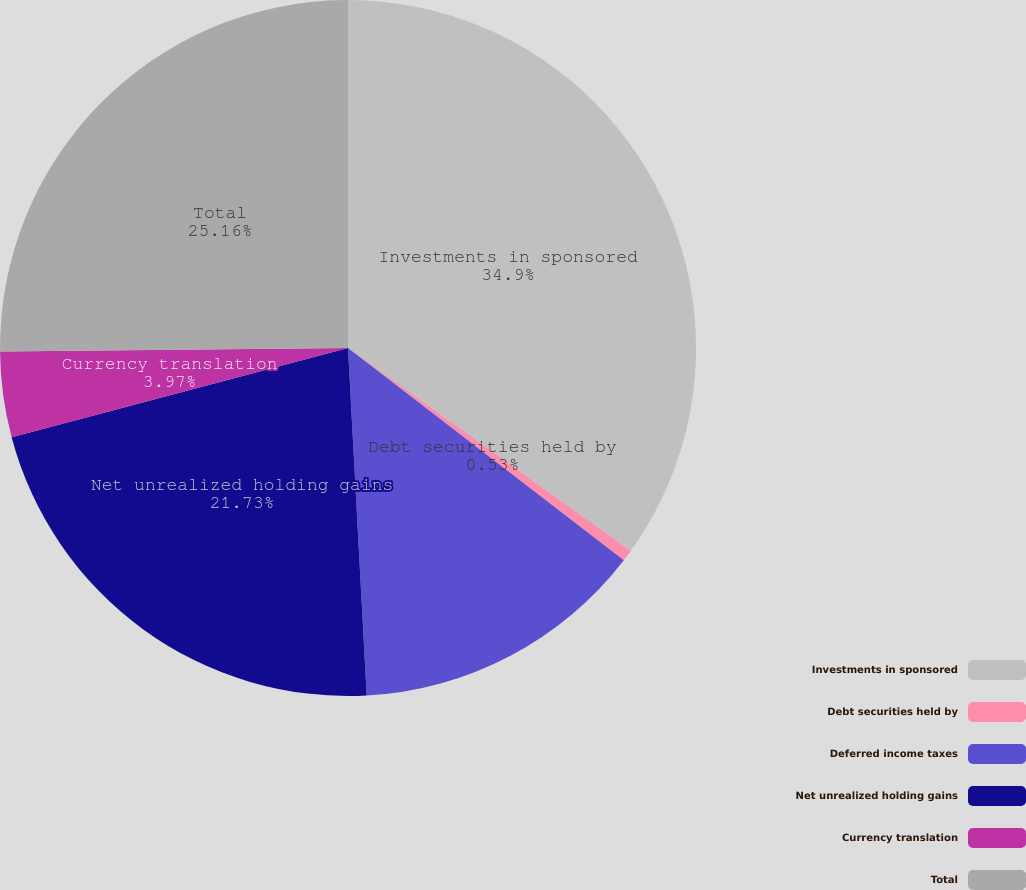Convert chart. <chart><loc_0><loc_0><loc_500><loc_500><pie_chart><fcel>Investments in sponsored<fcel>Debt securities held by<fcel>Deferred income taxes<fcel>Net unrealized holding gains<fcel>Currency translation<fcel>Total<nl><fcel>34.91%<fcel>0.53%<fcel>13.71%<fcel>21.73%<fcel>3.97%<fcel>25.16%<nl></chart> 